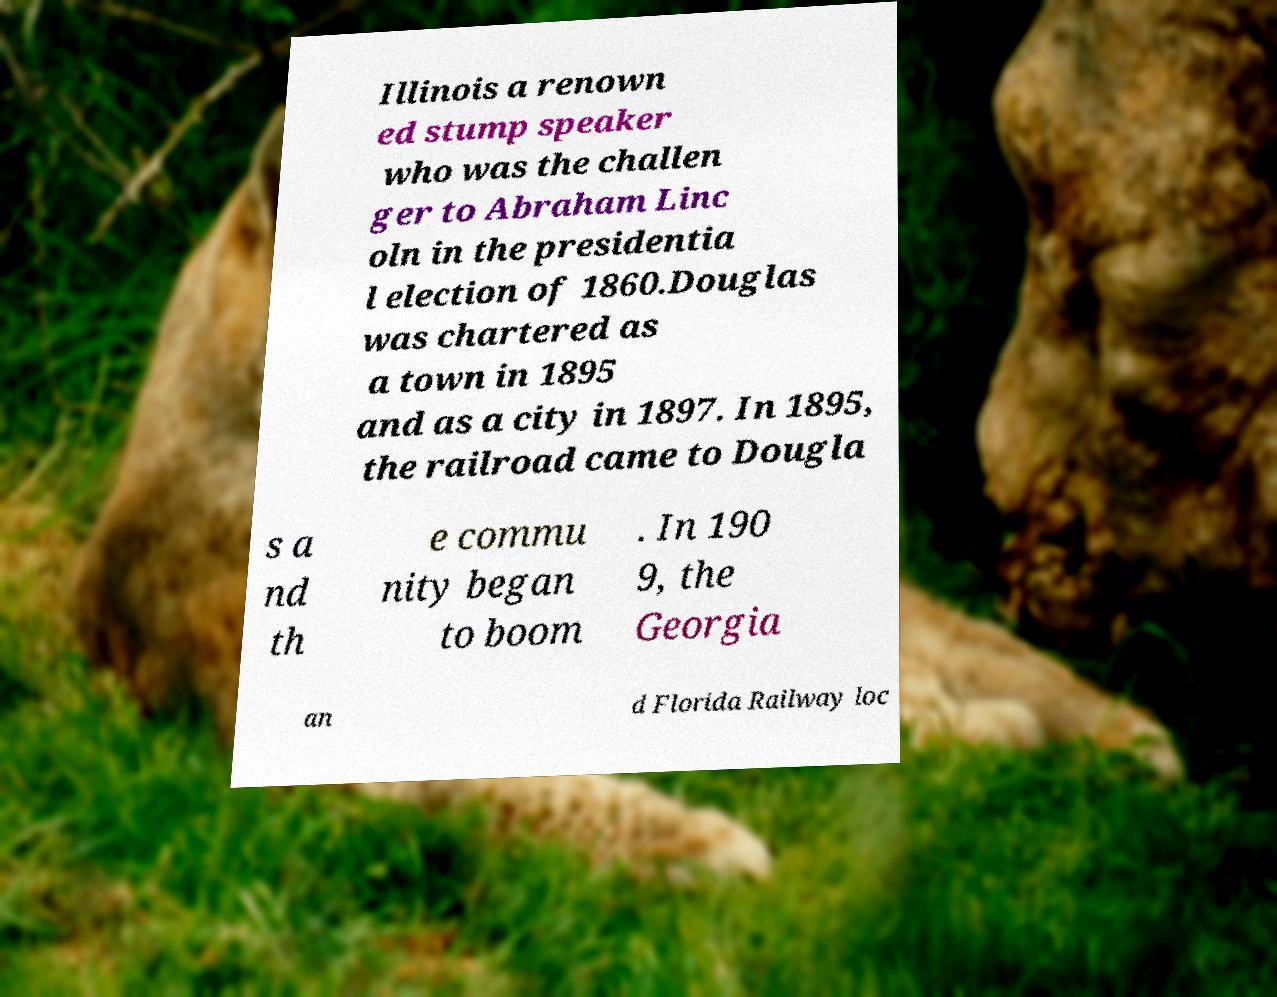Please read and relay the text visible in this image. What does it say? Illinois a renown ed stump speaker who was the challen ger to Abraham Linc oln in the presidentia l election of 1860.Douglas was chartered as a town in 1895 and as a city in 1897. In 1895, the railroad came to Dougla s a nd th e commu nity began to boom . In 190 9, the Georgia an d Florida Railway loc 